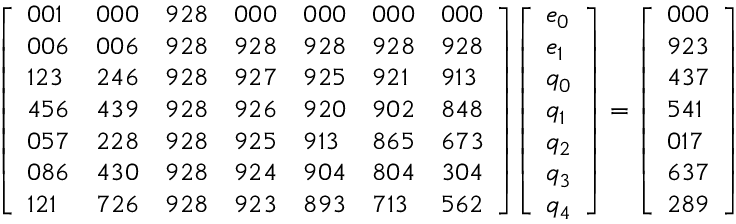<formula> <loc_0><loc_0><loc_500><loc_500>{ \left [ \begin{array} { l l l l l l l } { 0 0 1 } & { 0 0 0 } & { 9 2 8 } & { 0 0 0 } & { 0 0 0 } & { 0 0 0 } & { 0 0 0 } \\ { 0 0 6 } & { 0 0 6 } & { 9 2 8 } & { 9 2 8 } & { 9 2 8 } & { 9 2 8 } & { 9 2 8 } \\ { 1 2 3 } & { 2 4 6 } & { 9 2 8 } & { 9 2 7 } & { 9 2 5 } & { 9 2 1 } & { 9 1 3 } \\ { 4 5 6 } & { 4 3 9 } & { 9 2 8 } & { 9 2 6 } & { 9 2 0 } & { 9 0 2 } & { 8 4 8 } \\ { 0 5 7 } & { 2 2 8 } & { 9 2 8 } & { 9 2 5 } & { 9 1 3 } & { 8 6 5 } & { 6 7 3 } \\ { 0 8 6 } & { 4 3 0 } & { 9 2 8 } & { 9 2 4 } & { 9 0 4 } & { 8 0 4 } & { 3 0 4 } \\ { 1 2 1 } & { 7 2 6 } & { 9 2 8 } & { 9 2 3 } & { 8 9 3 } & { 7 1 3 } & { 5 6 2 } \end{array} \right ] } { \left [ \begin{array} { l } { e _ { 0 } } \\ { e _ { 1 } } \\ { q _ { 0 } } \\ { q _ { 1 } } \\ { q _ { 2 } } \\ { q _ { 3 } } \\ { q _ { 4 } } \end{array} \right ] } = { \left [ \begin{array} { l } { 0 0 0 } \\ { 9 2 3 } \\ { 4 3 7 } \\ { 5 4 1 } \\ { 0 1 7 } \\ { 6 3 7 } \\ { 2 8 9 } \end{array} \right ] }</formula> 